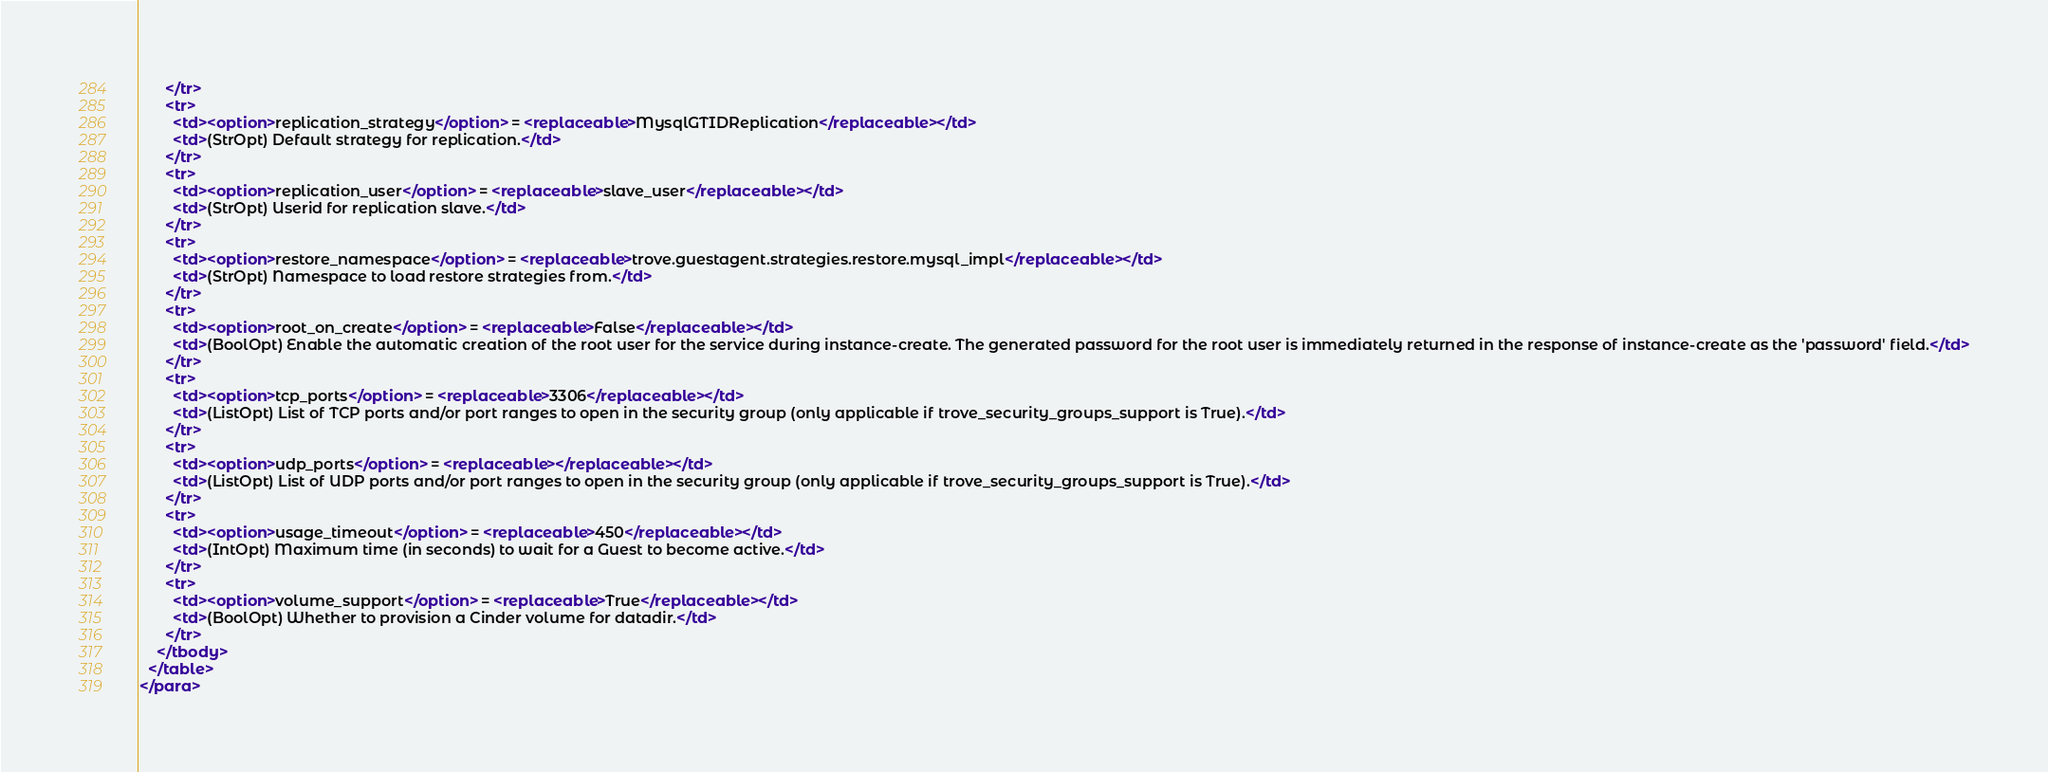<code> <loc_0><loc_0><loc_500><loc_500><_XML_>      </tr>
      <tr>
        <td><option>replication_strategy</option> = <replaceable>MysqlGTIDReplication</replaceable></td>
        <td>(StrOpt) Default strategy for replication.</td>
      </tr>
      <tr>
        <td><option>replication_user</option> = <replaceable>slave_user</replaceable></td>
        <td>(StrOpt) Userid for replication slave.</td>
      </tr>
      <tr>
        <td><option>restore_namespace</option> = <replaceable>trove.guestagent.strategies.restore.mysql_impl</replaceable></td>
        <td>(StrOpt) Namespace to load restore strategies from.</td>
      </tr>
      <tr>
        <td><option>root_on_create</option> = <replaceable>False</replaceable></td>
        <td>(BoolOpt) Enable the automatic creation of the root user for the service during instance-create. The generated password for the root user is immediately returned in the response of instance-create as the 'password' field.</td>
      </tr>
      <tr>
        <td><option>tcp_ports</option> = <replaceable>3306</replaceable></td>
        <td>(ListOpt) List of TCP ports and/or port ranges to open in the security group (only applicable if trove_security_groups_support is True).</td>
      </tr>
      <tr>
        <td><option>udp_ports</option> = <replaceable></replaceable></td>
        <td>(ListOpt) List of UDP ports and/or port ranges to open in the security group (only applicable if trove_security_groups_support is True).</td>
      </tr>
      <tr>
        <td><option>usage_timeout</option> = <replaceable>450</replaceable></td>
        <td>(IntOpt) Maximum time (in seconds) to wait for a Guest to become active.</td>
      </tr>
      <tr>
        <td><option>volume_support</option> = <replaceable>True</replaceable></td>
        <td>(BoolOpt) Whether to provision a Cinder volume for datadir.</td>
      </tr>
    </tbody>
  </table>
</para>
</code> 